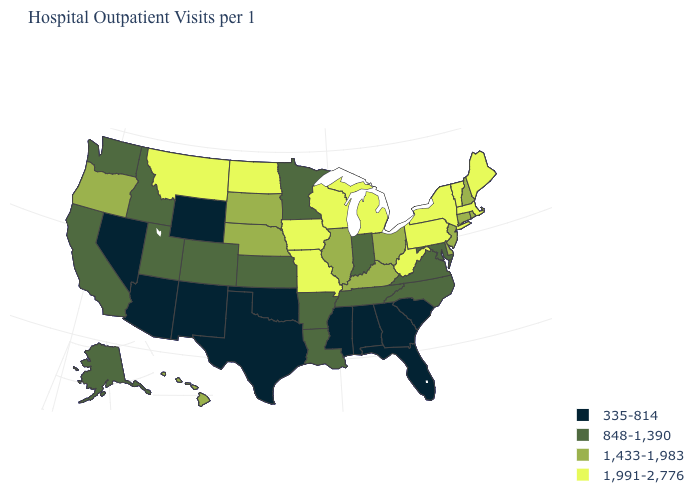What is the highest value in the USA?
Short answer required. 1,991-2,776. Which states hav the highest value in the West?
Answer briefly. Montana. What is the value of Colorado?
Write a very short answer. 848-1,390. Name the states that have a value in the range 1,433-1,983?
Answer briefly. Connecticut, Delaware, Hawaii, Illinois, Kentucky, Nebraska, New Hampshire, New Jersey, Ohio, Oregon, Rhode Island, South Dakota. Among the states that border South Carolina , which have the lowest value?
Short answer required. Georgia. What is the highest value in the USA?
Answer briefly. 1,991-2,776. What is the value of New Hampshire?
Quick response, please. 1,433-1,983. Name the states that have a value in the range 335-814?
Quick response, please. Alabama, Arizona, Florida, Georgia, Mississippi, Nevada, New Mexico, Oklahoma, South Carolina, Texas, Wyoming. Does the first symbol in the legend represent the smallest category?
Write a very short answer. Yes. Which states have the lowest value in the Northeast?
Answer briefly. Connecticut, New Hampshire, New Jersey, Rhode Island. Name the states that have a value in the range 848-1,390?
Answer briefly. Alaska, Arkansas, California, Colorado, Idaho, Indiana, Kansas, Louisiana, Maryland, Minnesota, North Carolina, Tennessee, Utah, Virginia, Washington. Which states have the highest value in the USA?
Concise answer only. Iowa, Maine, Massachusetts, Michigan, Missouri, Montana, New York, North Dakota, Pennsylvania, Vermont, West Virginia, Wisconsin. What is the value of Missouri?
Give a very brief answer. 1,991-2,776. Does California have a higher value than Maryland?
Short answer required. No. Does the map have missing data?
Quick response, please. No. 